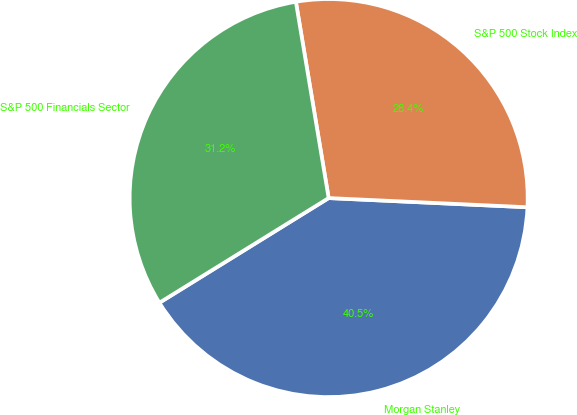Convert chart to OTSL. <chart><loc_0><loc_0><loc_500><loc_500><pie_chart><fcel>Morgan Stanley<fcel>S&P 500 Stock Index<fcel>S&P 500 Financials Sector<nl><fcel>40.45%<fcel>28.37%<fcel>31.18%<nl></chart> 